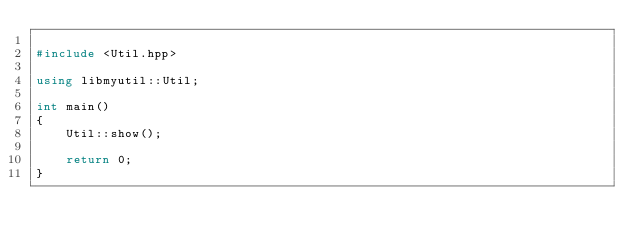Convert code to text. <code><loc_0><loc_0><loc_500><loc_500><_C++_>
#include <Util.hpp>

using libmyutil::Util;

int main()
{
    Util::show();

    return 0;
}
</code> 